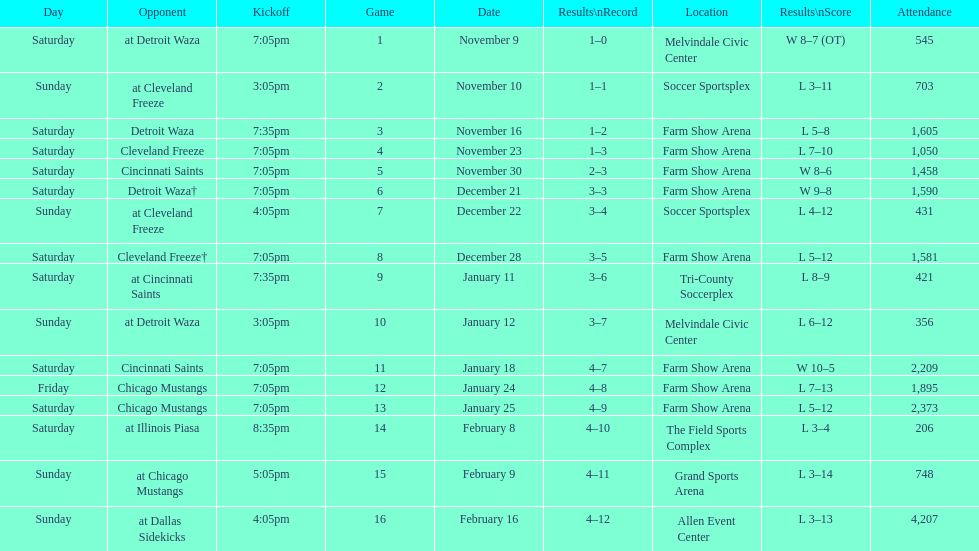Which opponent is listed after cleveland freeze in the table? Detroit Waza. 